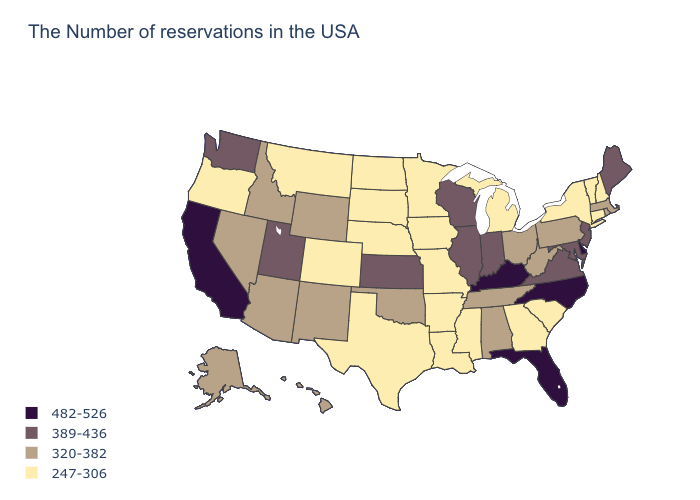What is the lowest value in the South?
Give a very brief answer. 247-306. What is the value of Louisiana?
Concise answer only. 247-306. Name the states that have a value in the range 389-436?
Give a very brief answer. Maine, New Jersey, Maryland, Virginia, Indiana, Wisconsin, Illinois, Kansas, Utah, Washington. How many symbols are there in the legend?
Keep it brief. 4. Does Illinois have a higher value than Wisconsin?
Write a very short answer. No. Does the first symbol in the legend represent the smallest category?
Short answer required. No. Name the states that have a value in the range 247-306?
Concise answer only. New Hampshire, Vermont, Connecticut, New York, South Carolina, Georgia, Michigan, Mississippi, Louisiana, Missouri, Arkansas, Minnesota, Iowa, Nebraska, Texas, South Dakota, North Dakota, Colorado, Montana, Oregon. What is the highest value in states that border Alabama?
Give a very brief answer. 482-526. Does North Carolina have the highest value in the USA?
Quick response, please. Yes. What is the value of Wyoming?
Give a very brief answer. 320-382. What is the value of North Carolina?
Keep it brief. 482-526. What is the lowest value in the South?
Quick response, please. 247-306. Does Louisiana have the highest value in the USA?
Give a very brief answer. No. Does Utah have the same value as Wisconsin?
Write a very short answer. Yes. 